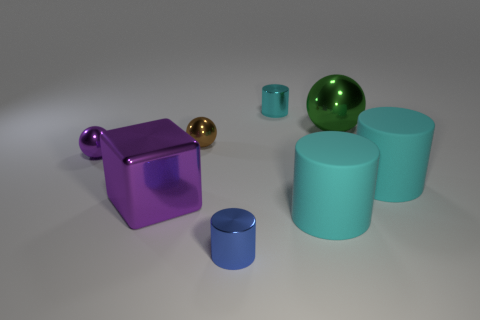Subtract all blue blocks. How many cyan cylinders are left? 3 Subtract 1 cylinders. How many cylinders are left? 3 Add 1 gray metal spheres. How many objects exist? 9 Subtract all spheres. How many objects are left? 5 Subtract all tiny cylinders. Subtract all big purple blocks. How many objects are left? 5 Add 1 brown shiny things. How many brown shiny things are left? 2 Add 6 purple metallic cubes. How many purple metallic cubes exist? 7 Subtract 0 red spheres. How many objects are left? 8 